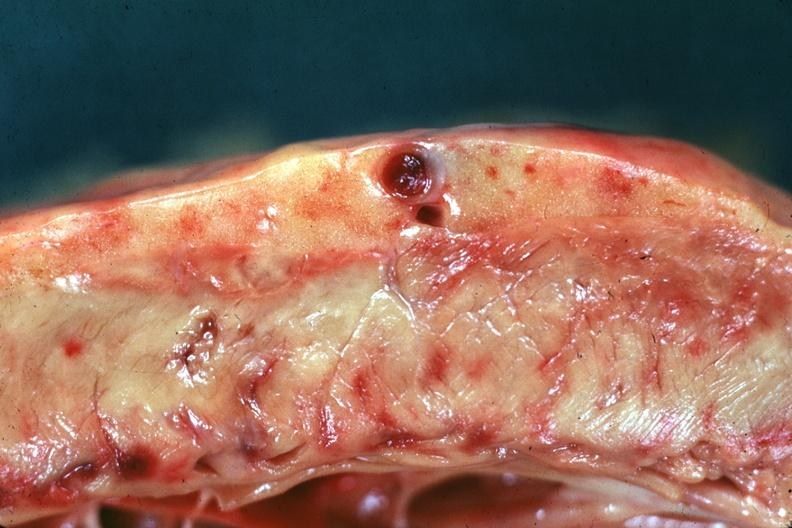what does this image show?
Answer the question using a single word or phrase. No hyperplasia 